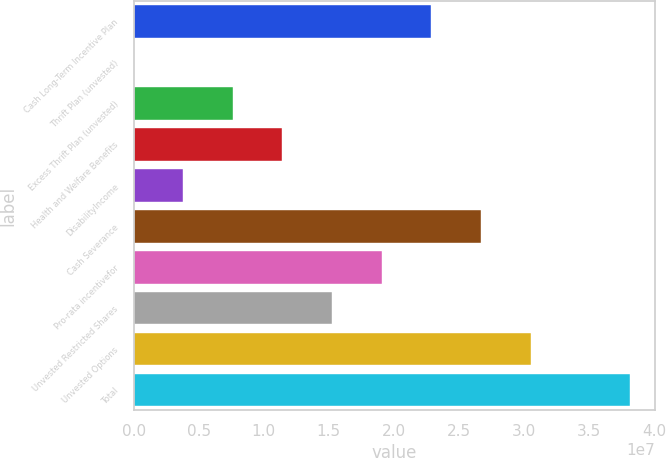Convert chart. <chart><loc_0><loc_0><loc_500><loc_500><bar_chart><fcel>Cash Long-Term Incentive Plan<fcel>Thrift Plan (unvested)<fcel>Excess Thrift Plan (unvested)<fcel>Health and Welfare Benefits<fcel>DisabilityIncome<fcel>Cash Severance<fcel>Pro-rata incentivefor<fcel>Unvested Restricted Shares<fcel>Unvested Options<fcel>Total<nl><fcel>2.28911e+07<fcel>1.5<fcel>7.63035e+06<fcel>1.14455e+07<fcel>3.81518e+06<fcel>2.67062e+07<fcel>1.90759e+07<fcel>1.52607e+07<fcel>3.05214e+07<fcel>3.81518e+07<nl></chart> 